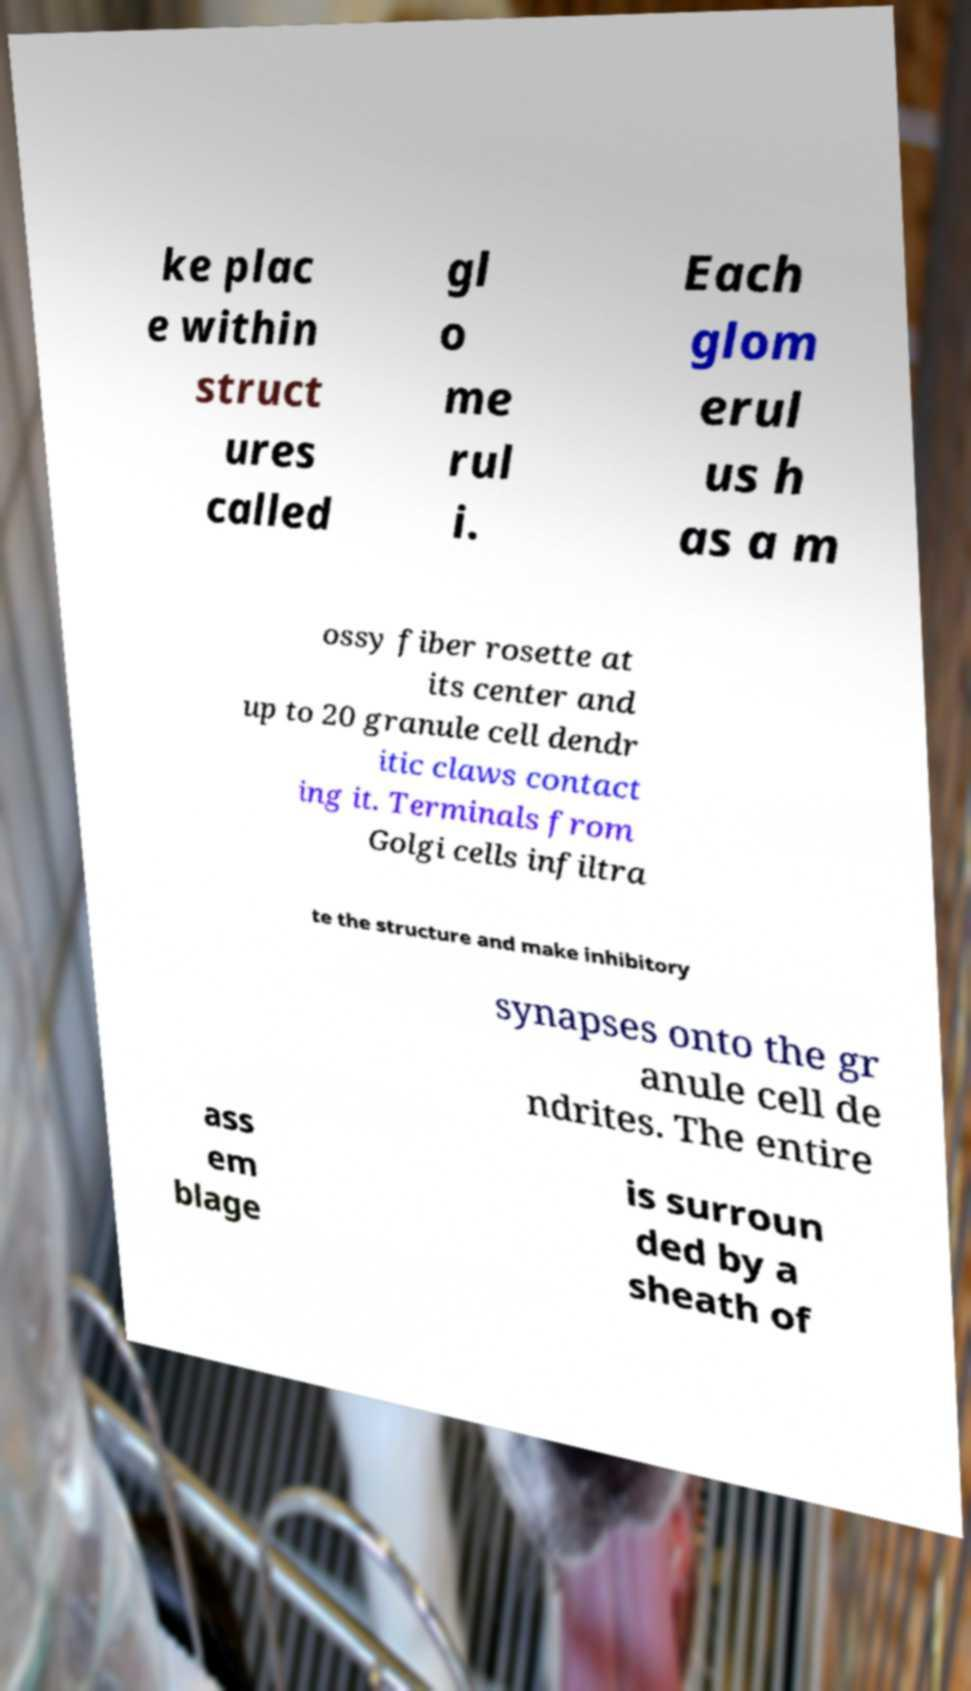Can you read and provide the text displayed in the image?This photo seems to have some interesting text. Can you extract and type it out for me? ke plac e within struct ures called gl o me rul i. Each glom erul us h as a m ossy fiber rosette at its center and up to 20 granule cell dendr itic claws contact ing it. Terminals from Golgi cells infiltra te the structure and make inhibitory synapses onto the gr anule cell de ndrites. The entire ass em blage is surroun ded by a sheath of 